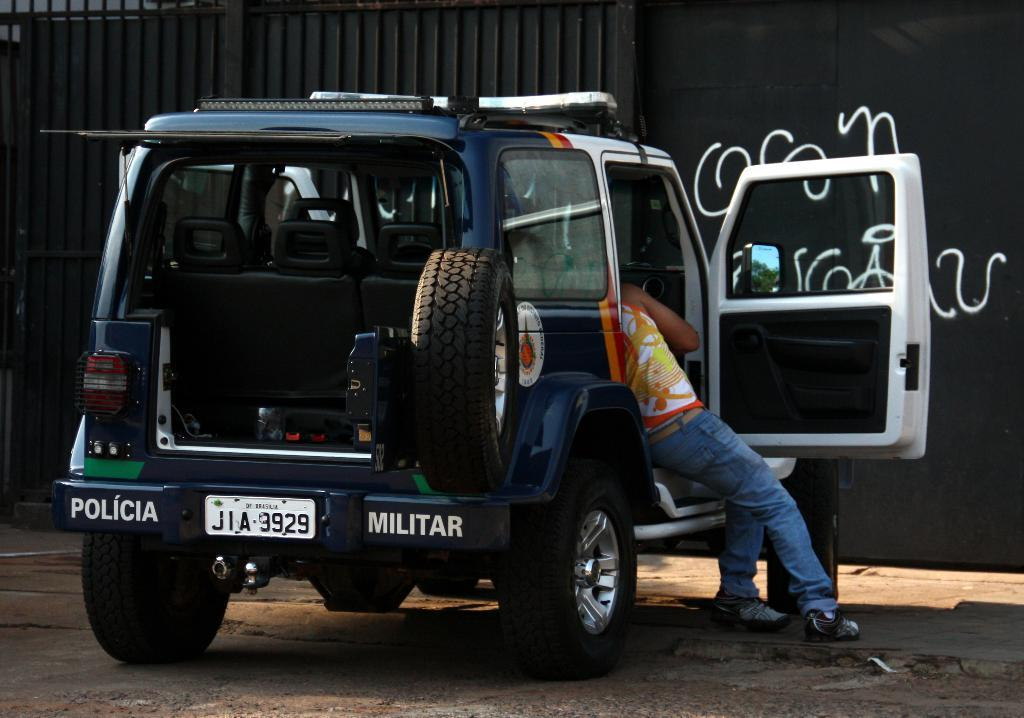What is the main subject in the center of the image? There is a vehicle in the center of the image. Can you describe the person inside the vehicle? There is a person inside the vehicle, but their appearance or actions are not specified. What can be seen in the background of the image? There is a wall and a gate in the background of the image. What is at the bottom of the image? There is a road at the bottom of the image. How many toys are scattered around the tent in the image? There is no tent or toys present in the image. 